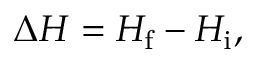Convert formula to latex. <formula><loc_0><loc_0><loc_500><loc_500>\Delta H = H _ { f } - H _ { i } ,</formula> 